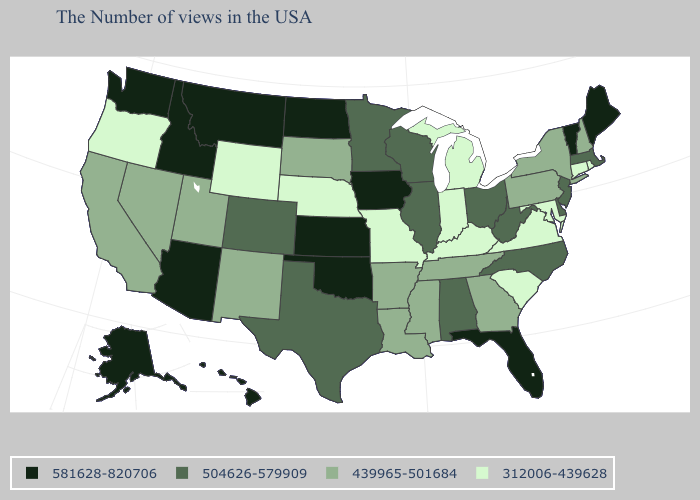Among the states that border North Dakota , which have the lowest value?
Concise answer only. South Dakota. What is the value of Louisiana?
Give a very brief answer. 439965-501684. Does Texas have a lower value than Nevada?
Give a very brief answer. No. What is the value of Montana?
Keep it brief. 581628-820706. What is the value of North Dakota?
Short answer required. 581628-820706. How many symbols are there in the legend?
Keep it brief. 4. How many symbols are there in the legend?
Concise answer only. 4. Does Virginia have the highest value in the USA?
Concise answer only. No. Is the legend a continuous bar?
Keep it brief. No. Does Michigan have a lower value than Wyoming?
Concise answer only. No. What is the highest value in the USA?
Keep it brief. 581628-820706. Among the states that border Kansas , which have the lowest value?
Give a very brief answer. Missouri, Nebraska. What is the value of Florida?
Be succinct. 581628-820706. What is the highest value in states that border West Virginia?
Be succinct. 504626-579909. What is the value of Michigan?
Be succinct. 312006-439628. 